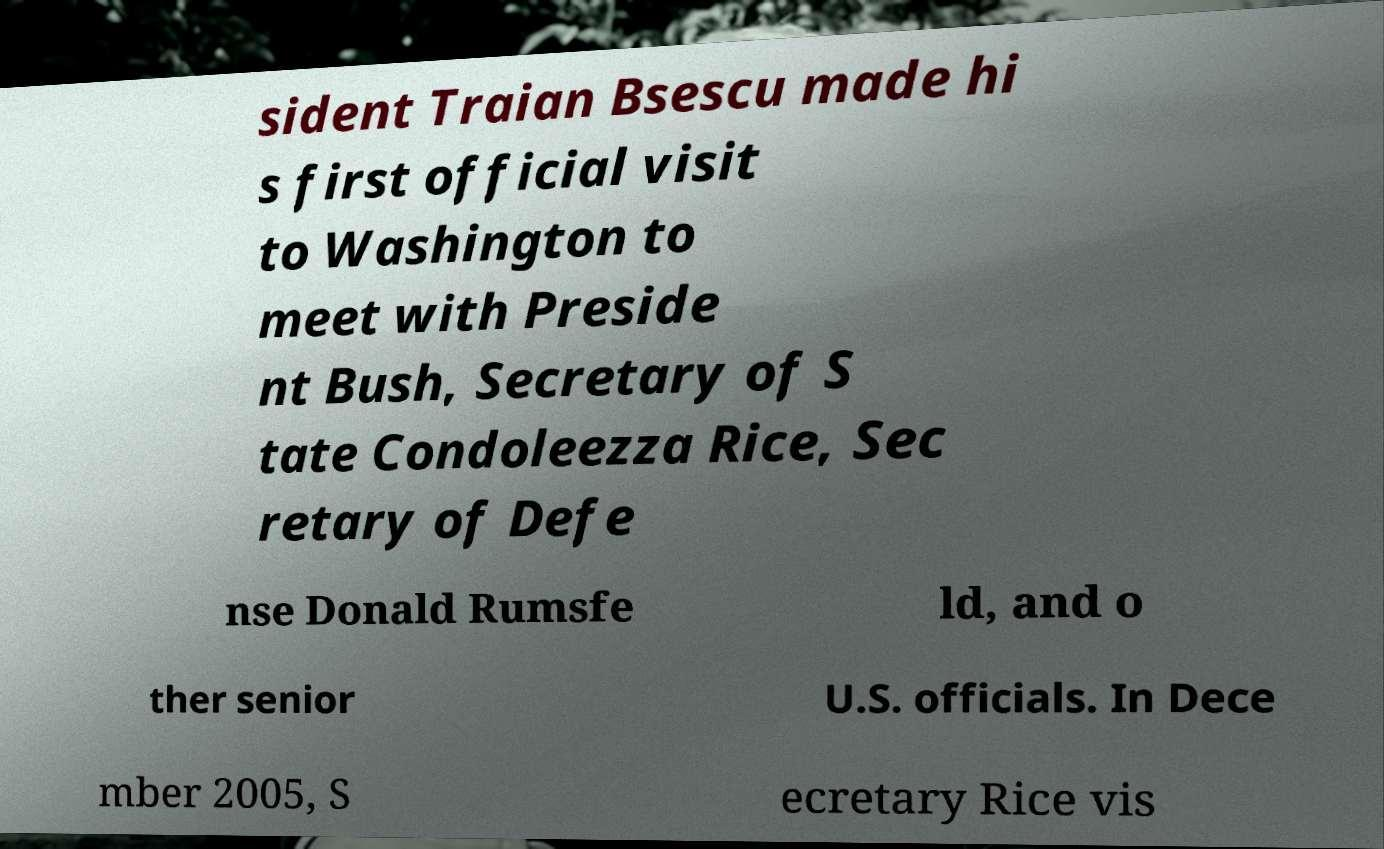For documentation purposes, I need the text within this image transcribed. Could you provide that? sident Traian Bsescu made hi s first official visit to Washington to meet with Preside nt Bush, Secretary of S tate Condoleezza Rice, Sec retary of Defe nse Donald Rumsfe ld, and o ther senior U.S. officials. In Dece mber 2005, S ecretary Rice vis 